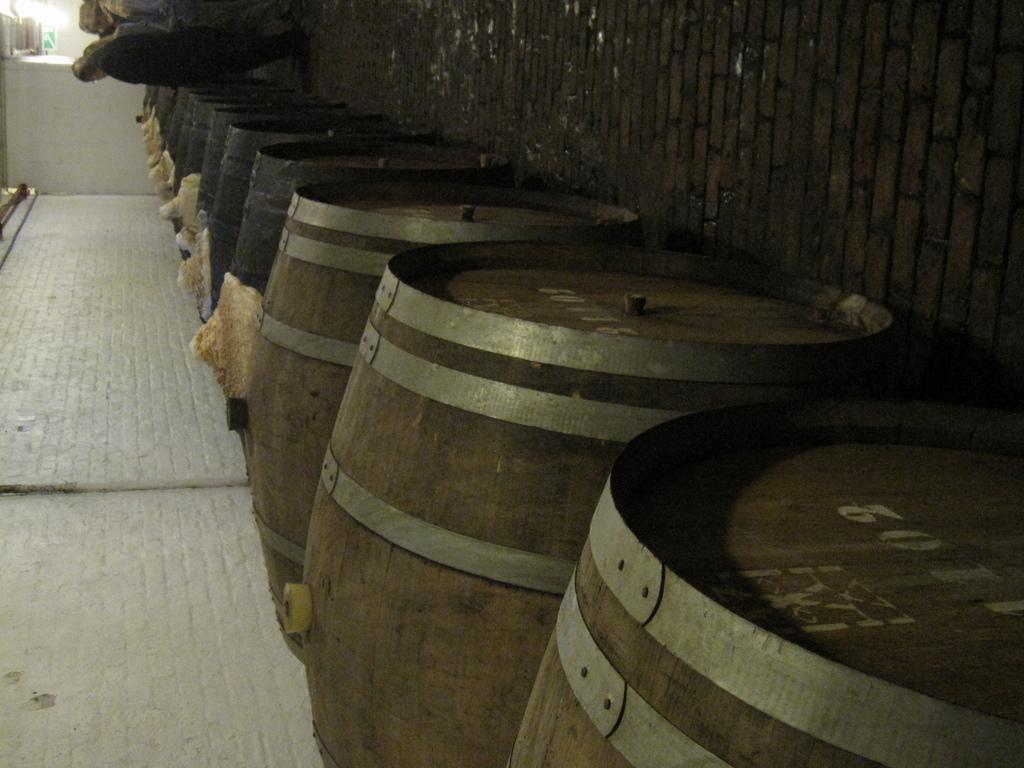Provide a one-sentence caption for the provided image. People looking at barrels with the first barrel having a white number 2 on it. 